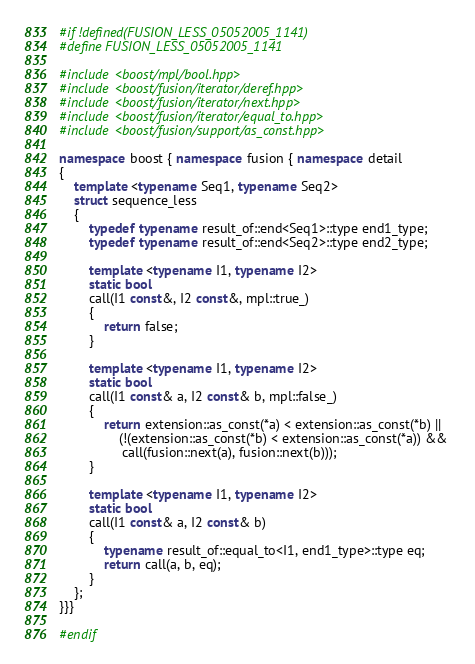Convert code to text. <code><loc_0><loc_0><loc_500><loc_500><_C++_>#if !defined(FUSION_LESS_05052005_1141)
#define FUSION_LESS_05052005_1141

#include <boost/mpl/bool.hpp>
#include <boost/fusion/iterator/deref.hpp>
#include <boost/fusion/iterator/next.hpp>
#include <boost/fusion/iterator/equal_to.hpp>
#include <boost/fusion/support/as_const.hpp>

namespace boost { namespace fusion { namespace detail
{
    template <typename Seq1, typename Seq2>
    struct sequence_less
    {
        typedef typename result_of::end<Seq1>::type end1_type;
        typedef typename result_of::end<Seq2>::type end2_type;

        template <typename I1, typename I2>
        static bool
        call(I1 const&, I2 const&, mpl::true_)
        {
            return false;
        }

        template <typename I1, typename I2>
        static bool
        call(I1 const& a, I2 const& b, mpl::false_)
        {
            return extension::as_const(*a) < extension::as_const(*b) ||
                (!(extension::as_const(*b) < extension::as_const(*a)) && 
                 call(fusion::next(a), fusion::next(b)));
        }

        template <typename I1, typename I2>
        static bool
        call(I1 const& a, I2 const& b)
        {
            typename result_of::equal_to<I1, end1_type>::type eq;
            return call(a, b, eq);
        }
    };
}}}

#endif
</code> 